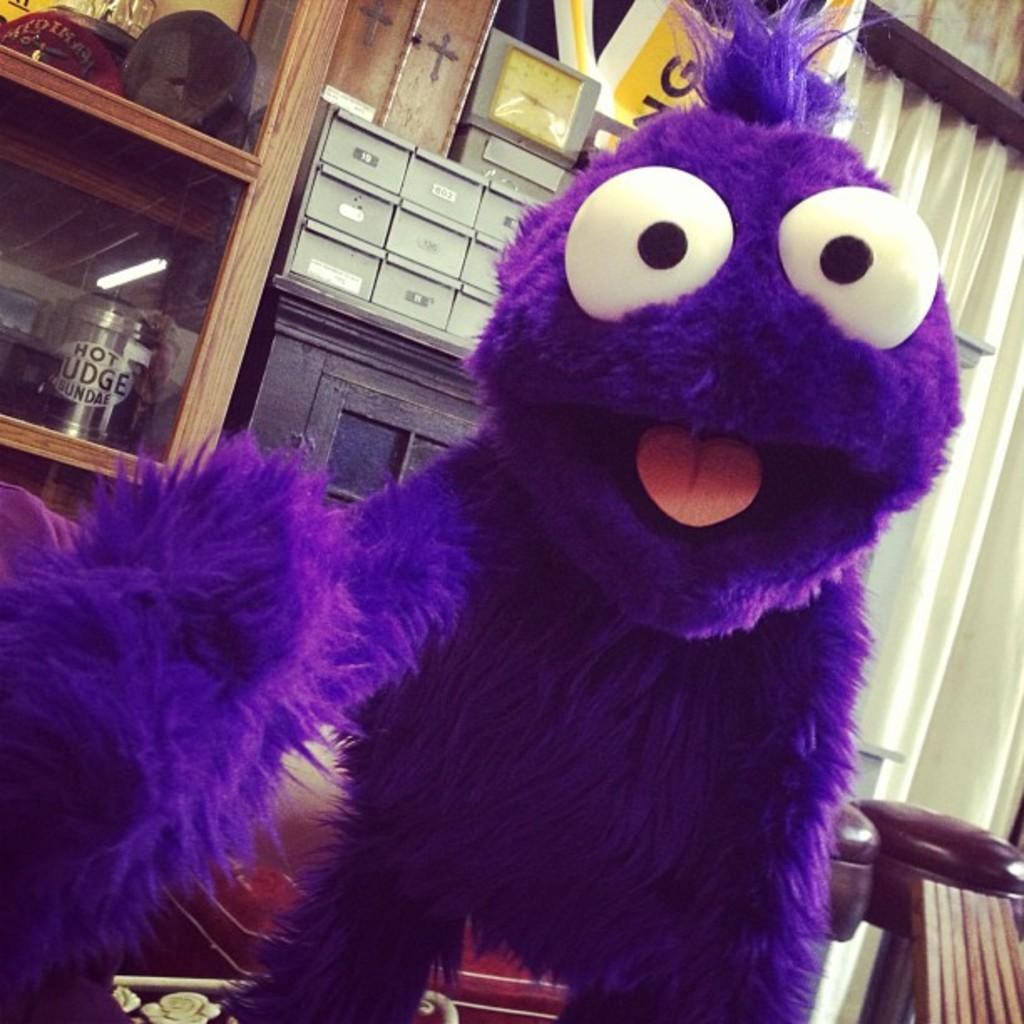Could you give a brief overview of what you see in this image? In this image, I can see a mascot. In the background, there are few objects. On the right side of the image, these are looking like stools and I can see a curtain hanging to a hanger. 